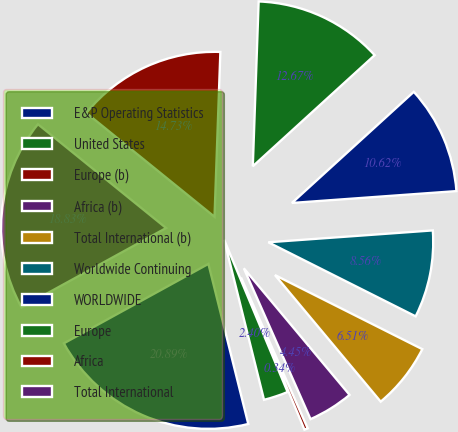Convert chart to OTSL. <chart><loc_0><loc_0><loc_500><loc_500><pie_chart><fcel>E&P Operating Statistics<fcel>United States<fcel>Europe (b)<fcel>Africa (b)<fcel>Total International (b)<fcel>Worldwide Continuing<fcel>WORLDWIDE<fcel>Europe<fcel>Africa<fcel>Total International<nl><fcel>20.89%<fcel>2.4%<fcel>0.34%<fcel>4.45%<fcel>6.51%<fcel>8.56%<fcel>10.62%<fcel>12.67%<fcel>14.73%<fcel>18.83%<nl></chart> 